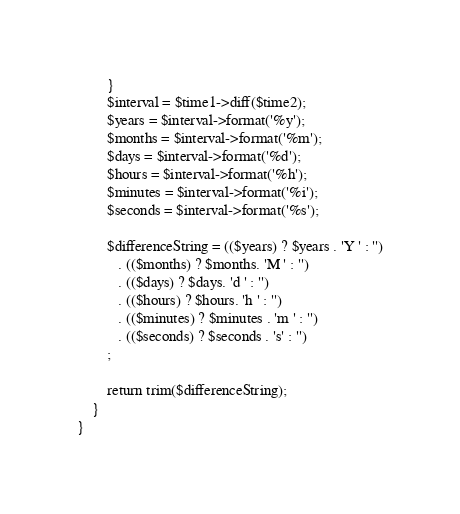Convert code to text. <code><loc_0><loc_0><loc_500><loc_500><_PHP_>        }
        $interval = $time1->diff($time2);
        $years = $interval->format('%y');
        $months = $interval->format('%m');
        $days = $interval->format('%d');
        $hours = $interval->format('%h');
        $minutes = $interval->format('%i');
        $seconds = $interval->format('%s');

        $differenceString = (($years) ? $years . 'Y ' : '')
           . (($months) ? $months. 'M ' : '')
           . (($days) ? $days. 'd ' : '')
           . (($hours) ? $hours. 'h ' : '')
           . (($minutes) ? $minutes . 'm ' : '')
           . (($seconds) ? $seconds . 's' : '')
        ;

        return trim($differenceString);
    }
}</code> 